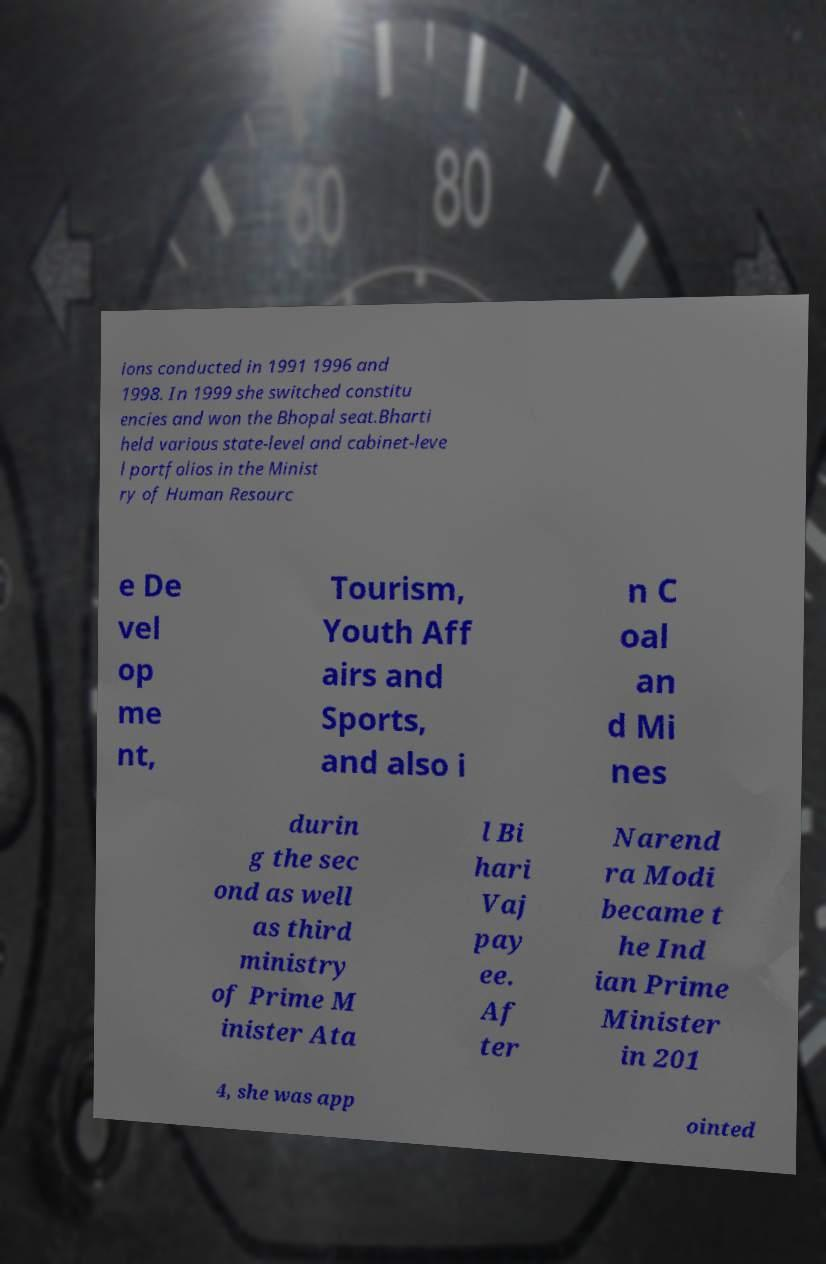There's text embedded in this image that I need extracted. Can you transcribe it verbatim? ions conducted in 1991 1996 and 1998. In 1999 she switched constitu encies and won the Bhopal seat.Bharti held various state-level and cabinet-leve l portfolios in the Minist ry of Human Resourc e De vel op me nt, Tourism, Youth Aff airs and Sports, and also i n C oal an d Mi nes durin g the sec ond as well as third ministry of Prime M inister Ata l Bi hari Vaj pay ee. Af ter Narend ra Modi became t he Ind ian Prime Minister in 201 4, she was app ointed 